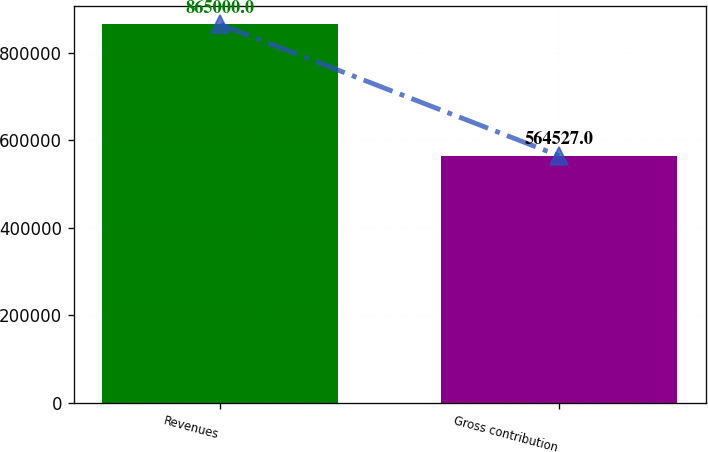Convert chart to OTSL. <chart><loc_0><loc_0><loc_500><loc_500><bar_chart><fcel>Revenues<fcel>Gross contribution<nl><fcel>865000<fcel>564527<nl></chart> 